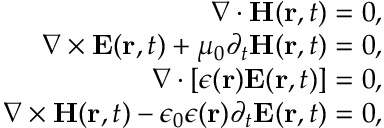<formula> <loc_0><loc_0><loc_500><loc_500>\begin{array} { r } { \nabla \cdot { H } ( { r } , t ) = 0 , } \\ { \nabla \times { E } ( { r } , t ) + \mu _ { 0 } \partial _ { t } { H } ( { r } , t ) = 0 , } \\ { \nabla \cdot [ \epsilon ( { r } ) { E } ( { r } , t ) ] = 0 , } \\ { \nabla \times { H } ( { r } , t ) - \epsilon _ { 0 } \epsilon ( { r } ) \partial _ { t } { E } ( { r } , t ) = 0 , } \end{array}</formula> 